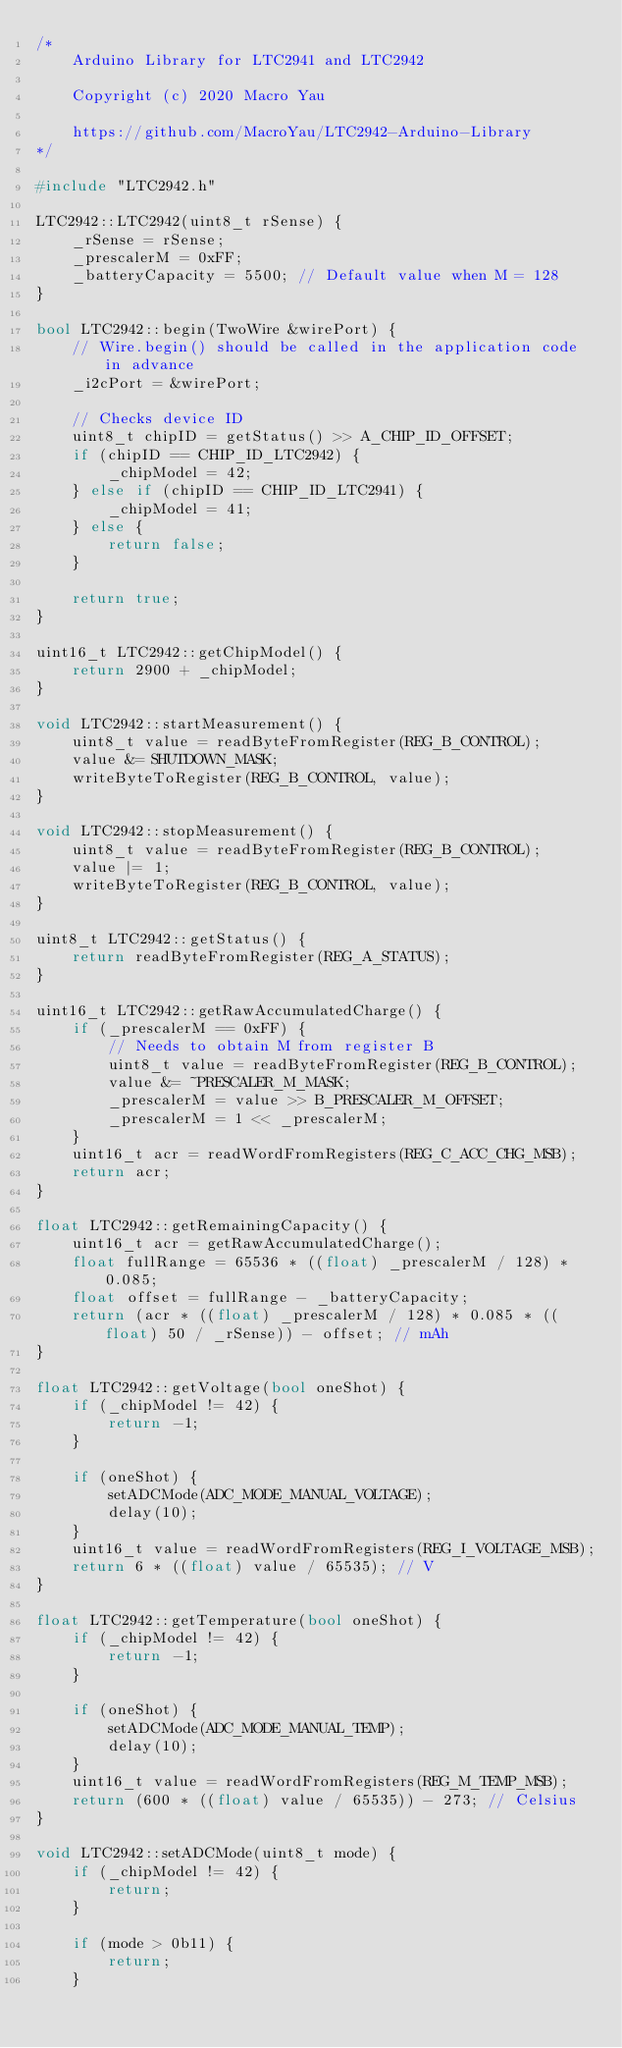<code> <loc_0><loc_0><loc_500><loc_500><_C++_>/*
	Arduino Library for LTC2941 and LTC2942
	
	Copyright (c) 2020 Macro Yau

	https://github.com/MacroYau/LTC2942-Arduino-Library
*/

#include "LTC2942.h"

LTC2942::LTC2942(uint8_t rSense) {
	_rSense = rSense;
	_prescalerM = 0xFF;
	_batteryCapacity = 5500; // Default value when M = 128
}

bool LTC2942::begin(TwoWire &wirePort) {
	// Wire.begin() should be called in the application code in advance
	_i2cPort = &wirePort;

	// Checks device ID
	uint8_t chipID = getStatus() >> A_CHIP_ID_OFFSET;
	if (chipID == CHIP_ID_LTC2942) {
		_chipModel = 42;
	} else if (chipID == CHIP_ID_LTC2941) {
		_chipModel = 41;
	} else {
		return false;
	}

	return true;
}

uint16_t LTC2942::getChipModel() {
	return 2900 + _chipModel;
}

void LTC2942::startMeasurement() {
	uint8_t value = readByteFromRegister(REG_B_CONTROL);
	value &= SHUTDOWN_MASK;
	writeByteToRegister(REG_B_CONTROL, value);
}

void LTC2942::stopMeasurement() {
	uint8_t value = readByteFromRegister(REG_B_CONTROL);
	value |= 1;
	writeByteToRegister(REG_B_CONTROL, value);
}

uint8_t LTC2942::getStatus() {
	return readByteFromRegister(REG_A_STATUS);
}

uint16_t LTC2942::getRawAccumulatedCharge() {
	if (_prescalerM == 0xFF) {
		// Needs to obtain M from register B
		uint8_t value = readByteFromRegister(REG_B_CONTROL);
		value &= ~PRESCALER_M_MASK;
		_prescalerM = value >> B_PRESCALER_M_OFFSET;
		_prescalerM = 1 << _prescalerM;
	}
	uint16_t acr = readWordFromRegisters(REG_C_ACC_CHG_MSB);
	return acr;
}

float LTC2942::getRemainingCapacity() {
	uint16_t acr = getRawAccumulatedCharge();
	float fullRange = 65536 * ((float) _prescalerM / 128) * 0.085;
	float offset = fullRange - _batteryCapacity;
	return (acr * ((float) _prescalerM / 128) * 0.085 * ((float) 50 / _rSense)) - offset; // mAh
}

float LTC2942::getVoltage(bool oneShot) {
	if (_chipModel != 42) {
		return -1;
	}

	if (oneShot) {
		setADCMode(ADC_MODE_MANUAL_VOLTAGE);
		delay(10);
	}
	uint16_t value = readWordFromRegisters(REG_I_VOLTAGE_MSB);
	return 6 * ((float) value / 65535); // V
}

float LTC2942::getTemperature(bool oneShot) {
	if (_chipModel != 42) {
		return -1;
	}

	if (oneShot) {
		setADCMode(ADC_MODE_MANUAL_TEMP);
		delay(10);
	}
	uint16_t value = readWordFromRegisters(REG_M_TEMP_MSB);
	return (600 * ((float) value / 65535)) - 273; // Celsius
}

void LTC2942::setADCMode(uint8_t mode) {
	if (_chipModel != 42) {
		return;
	}

	if (mode > 0b11) {
		return;
	}
</code> 